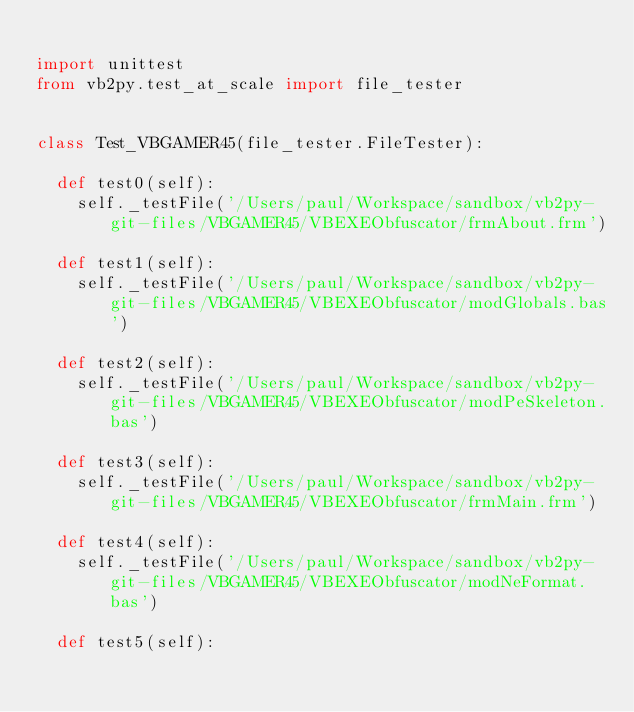Convert code to text. <code><loc_0><loc_0><loc_500><loc_500><_Python_>
import unittest
from vb2py.test_at_scale import file_tester


class Test_VBGAMER45(file_tester.FileTester):

	def test0(self):
		self._testFile('/Users/paul/Workspace/sandbox/vb2py-git-files/VBGAMER45/VBEXEObfuscator/frmAbout.frm')

	def test1(self):
		self._testFile('/Users/paul/Workspace/sandbox/vb2py-git-files/VBGAMER45/VBEXEObfuscator/modGlobals.bas')

	def test2(self):
		self._testFile('/Users/paul/Workspace/sandbox/vb2py-git-files/VBGAMER45/VBEXEObfuscator/modPeSkeleton.bas')

	def test3(self):
		self._testFile('/Users/paul/Workspace/sandbox/vb2py-git-files/VBGAMER45/VBEXEObfuscator/frmMain.frm')

	def test4(self):
		self._testFile('/Users/paul/Workspace/sandbox/vb2py-git-files/VBGAMER45/VBEXEObfuscator/modNeFormat.bas')

	def test5(self):</code> 